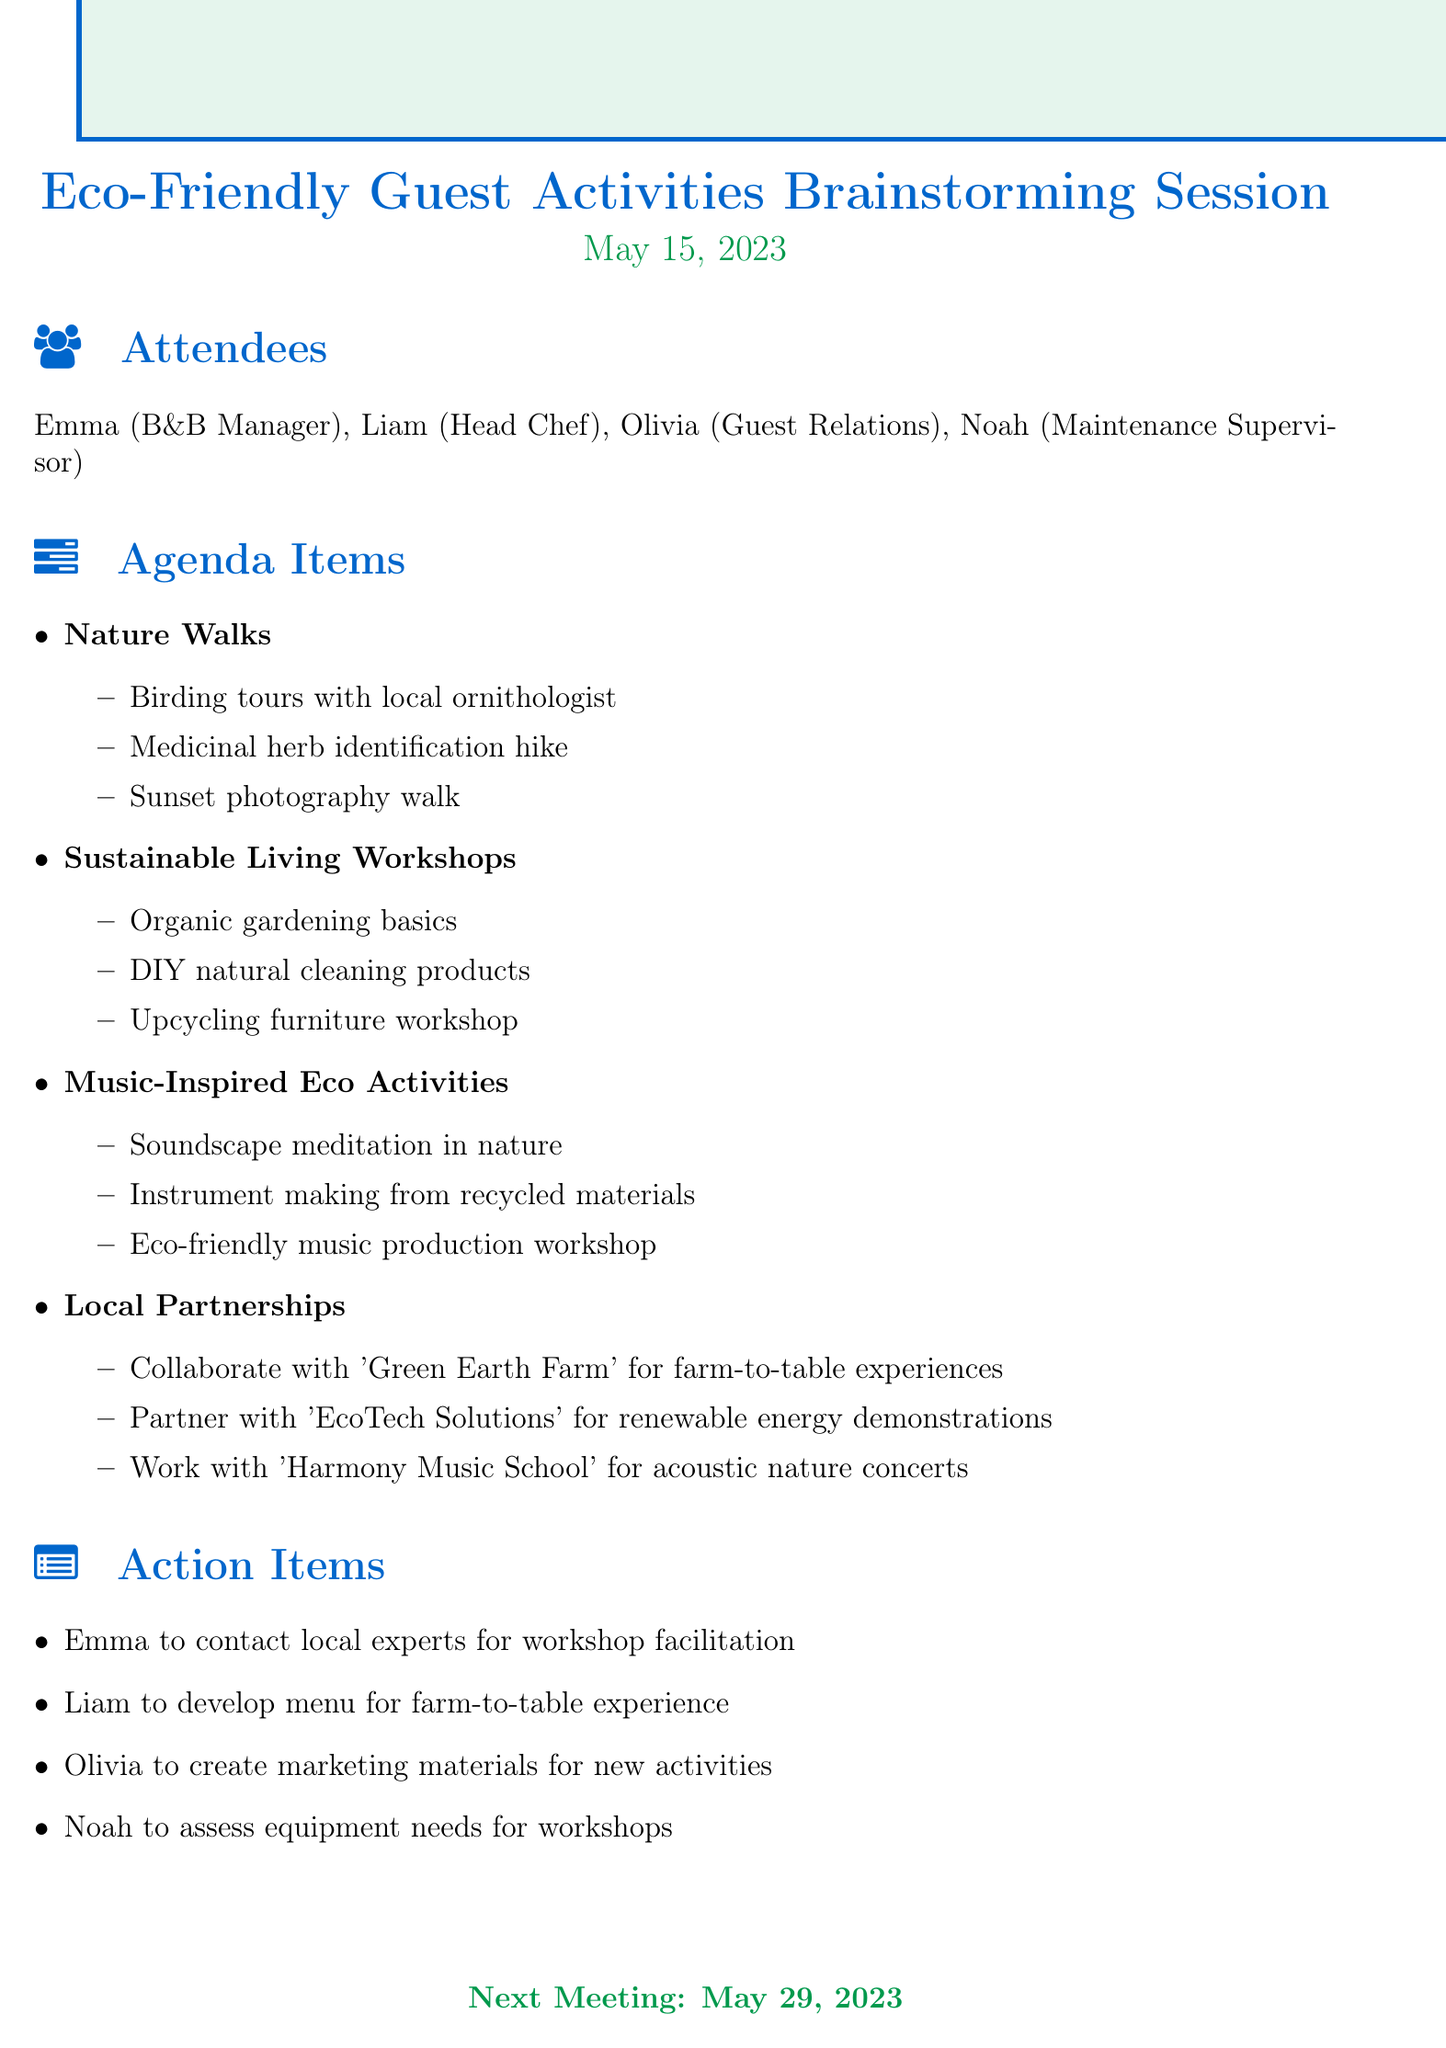What is the date of the meeting? The date of the meeting is provided in the document as May 15, 2023.
Answer: May 15, 2023 Who is the Head Chef? The document lists Liam as the Head Chef among the attendees.
Answer: Liam What are two topics discussed in the meeting? The document includes several topics; two examples are "Nature Walks" and "Sustainable Living Workshops."
Answer: Nature Walks, Sustainable Living Workshops What is one proposed activity for Sustainable Living Workshops? The document lists ideas for workshops, one of which is "DIY natural cleaning products."
Answer: DIY natural cleaning products Who is responsible for creating marketing materials? The action items specify that Olivia is responsible for creating marketing materials for new activities.
Answer: Olivia What is scheduled for the next meeting date? The document provides the next meeting date as May 29, 2023.
Answer: May 29, 2023 What type of activity is "Soundscape meditation in nature"? This activity falls under the topic of "Music-Inspired Eco Activities" mentioned in the agenda items.
Answer: Music-Inspired Eco Activities Which partnership is related to renewable energy? The action item mentions working with "EcoTech Solutions" for renewable energy demonstrations.
Answer: EcoTech Solutions 